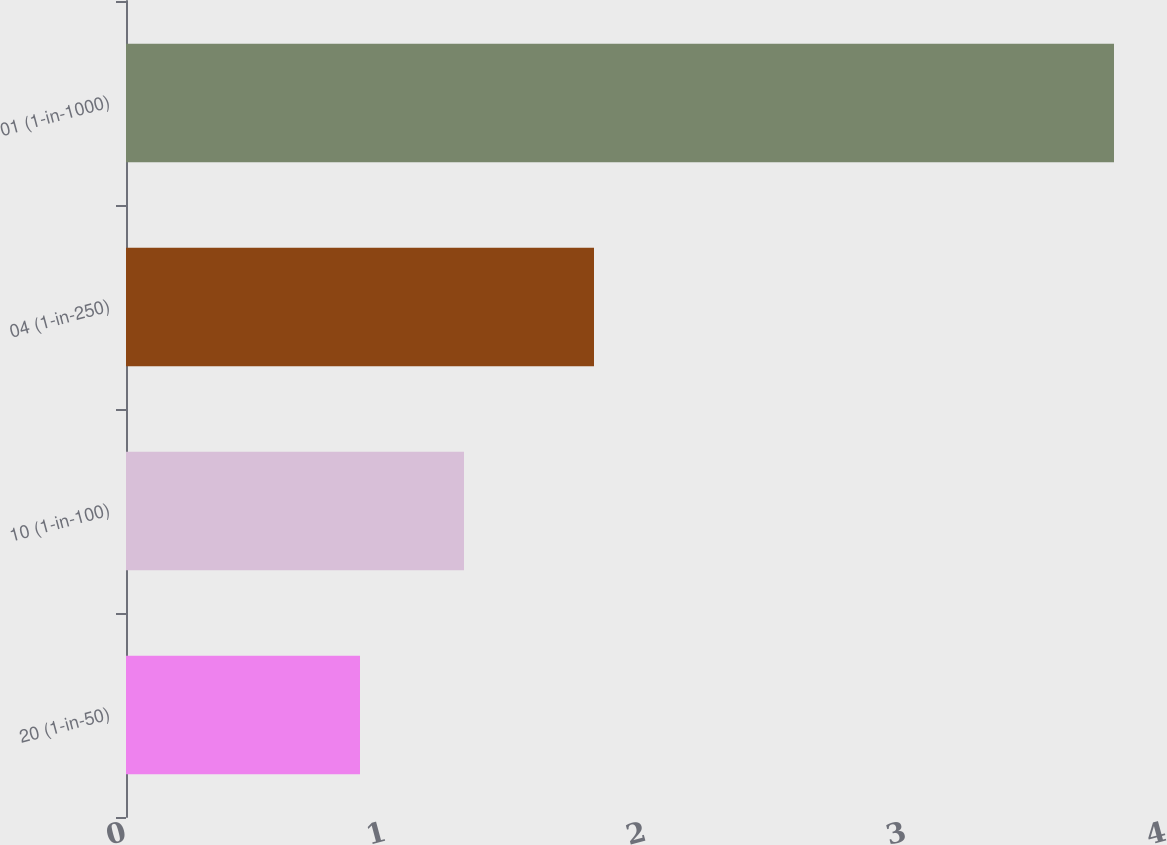Convert chart. <chart><loc_0><loc_0><loc_500><loc_500><bar_chart><fcel>20 (1-in-50)<fcel>10 (1-in-100)<fcel>04 (1-in-250)<fcel>01 (1-in-1000)<nl><fcel>0.9<fcel>1.3<fcel>1.8<fcel>3.8<nl></chart> 